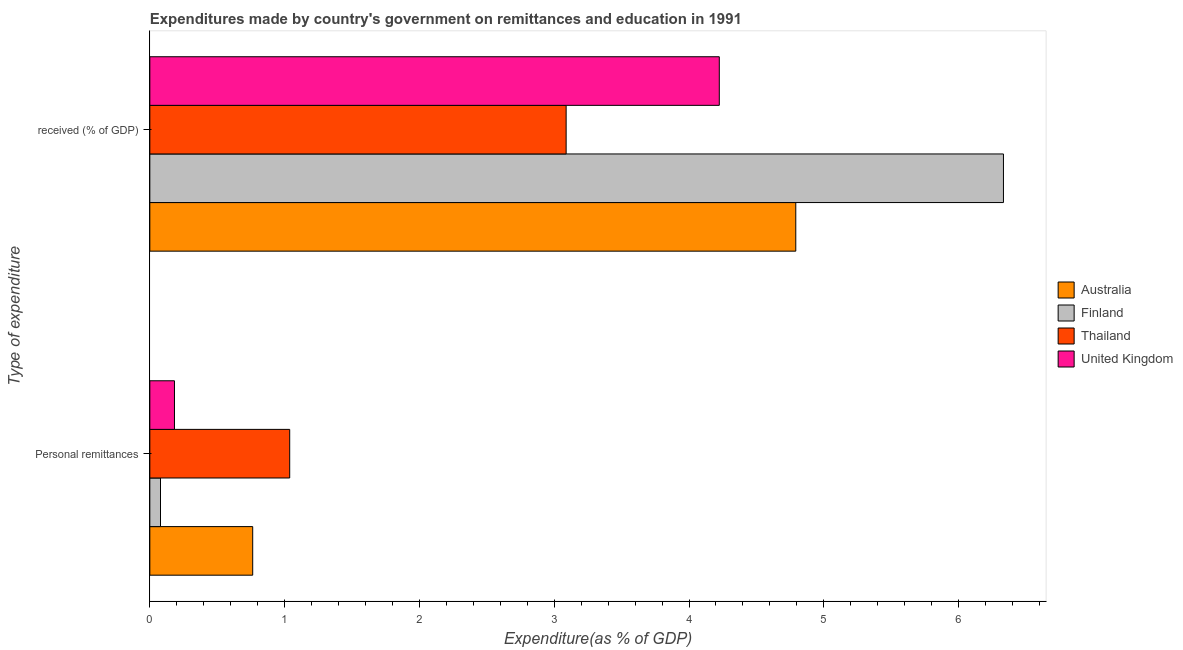How many different coloured bars are there?
Your response must be concise. 4. Are the number of bars per tick equal to the number of legend labels?
Your answer should be very brief. Yes. Are the number of bars on each tick of the Y-axis equal?
Ensure brevity in your answer.  Yes. How many bars are there on the 1st tick from the top?
Offer a very short reply. 4. What is the label of the 2nd group of bars from the top?
Your response must be concise. Personal remittances. What is the expenditure in education in Thailand?
Ensure brevity in your answer.  3.09. Across all countries, what is the maximum expenditure in education?
Offer a terse response. 6.33. Across all countries, what is the minimum expenditure in education?
Your response must be concise. 3.09. In which country was the expenditure in personal remittances maximum?
Provide a short and direct response. Thailand. In which country was the expenditure in education minimum?
Ensure brevity in your answer.  Thailand. What is the total expenditure in personal remittances in the graph?
Provide a succinct answer. 2.06. What is the difference between the expenditure in education in Thailand and that in United Kingdom?
Make the answer very short. -1.14. What is the difference between the expenditure in personal remittances in Australia and the expenditure in education in Thailand?
Ensure brevity in your answer.  -2.33. What is the average expenditure in personal remittances per country?
Provide a short and direct response. 0.52. What is the difference between the expenditure in education and expenditure in personal remittances in Thailand?
Keep it short and to the point. 2.05. In how many countries, is the expenditure in personal remittances greater than 4.4 %?
Keep it short and to the point. 0. What is the ratio of the expenditure in education in Australia to that in Thailand?
Offer a very short reply. 1.55. What does the 4th bar from the bottom in  received (% of GDP) represents?
Keep it short and to the point. United Kingdom. Are all the bars in the graph horizontal?
Give a very brief answer. Yes. What is the difference between two consecutive major ticks on the X-axis?
Make the answer very short. 1. Does the graph contain any zero values?
Your answer should be compact. No. Does the graph contain grids?
Your answer should be compact. No. Where does the legend appear in the graph?
Keep it short and to the point. Center right. How many legend labels are there?
Keep it short and to the point. 4. How are the legend labels stacked?
Make the answer very short. Vertical. What is the title of the graph?
Offer a very short reply. Expenditures made by country's government on remittances and education in 1991. Does "Norway" appear as one of the legend labels in the graph?
Provide a short and direct response. No. What is the label or title of the X-axis?
Provide a succinct answer. Expenditure(as % of GDP). What is the label or title of the Y-axis?
Ensure brevity in your answer.  Type of expenditure. What is the Expenditure(as % of GDP) in Australia in Personal remittances?
Offer a very short reply. 0.76. What is the Expenditure(as % of GDP) in Finland in Personal remittances?
Your answer should be very brief. 0.08. What is the Expenditure(as % of GDP) of Thailand in Personal remittances?
Your response must be concise. 1.04. What is the Expenditure(as % of GDP) in United Kingdom in Personal remittances?
Give a very brief answer. 0.18. What is the Expenditure(as % of GDP) in Australia in  received (% of GDP)?
Offer a terse response. 4.79. What is the Expenditure(as % of GDP) of Finland in  received (% of GDP)?
Offer a terse response. 6.33. What is the Expenditure(as % of GDP) in Thailand in  received (% of GDP)?
Ensure brevity in your answer.  3.09. What is the Expenditure(as % of GDP) of United Kingdom in  received (% of GDP)?
Offer a terse response. 4.22. Across all Type of expenditure, what is the maximum Expenditure(as % of GDP) of Australia?
Make the answer very short. 4.79. Across all Type of expenditure, what is the maximum Expenditure(as % of GDP) in Finland?
Provide a short and direct response. 6.33. Across all Type of expenditure, what is the maximum Expenditure(as % of GDP) in Thailand?
Make the answer very short. 3.09. Across all Type of expenditure, what is the maximum Expenditure(as % of GDP) of United Kingdom?
Provide a short and direct response. 4.22. Across all Type of expenditure, what is the minimum Expenditure(as % of GDP) in Australia?
Ensure brevity in your answer.  0.76. Across all Type of expenditure, what is the minimum Expenditure(as % of GDP) in Finland?
Keep it short and to the point. 0.08. Across all Type of expenditure, what is the minimum Expenditure(as % of GDP) of Thailand?
Offer a terse response. 1.04. Across all Type of expenditure, what is the minimum Expenditure(as % of GDP) of United Kingdom?
Make the answer very short. 0.18. What is the total Expenditure(as % of GDP) in Australia in the graph?
Your answer should be compact. 5.56. What is the total Expenditure(as % of GDP) of Finland in the graph?
Your answer should be very brief. 6.41. What is the total Expenditure(as % of GDP) of Thailand in the graph?
Give a very brief answer. 4.13. What is the total Expenditure(as % of GDP) in United Kingdom in the graph?
Your response must be concise. 4.41. What is the difference between the Expenditure(as % of GDP) in Australia in Personal remittances and that in  received (% of GDP)?
Ensure brevity in your answer.  -4.03. What is the difference between the Expenditure(as % of GDP) of Finland in Personal remittances and that in  received (% of GDP)?
Provide a short and direct response. -6.25. What is the difference between the Expenditure(as % of GDP) in Thailand in Personal remittances and that in  received (% of GDP)?
Offer a very short reply. -2.05. What is the difference between the Expenditure(as % of GDP) in United Kingdom in Personal remittances and that in  received (% of GDP)?
Provide a succinct answer. -4.04. What is the difference between the Expenditure(as % of GDP) of Australia in Personal remittances and the Expenditure(as % of GDP) of Finland in  received (% of GDP)?
Give a very brief answer. -5.57. What is the difference between the Expenditure(as % of GDP) in Australia in Personal remittances and the Expenditure(as % of GDP) in Thailand in  received (% of GDP)?
Your answer should be very brief. -2.33. What is the difference between the Expenditure(as % of GDP) in Australia in Personal remittances and the Expenditure(as % of GDP) in United Kingdom in  received (% of GDP)?
Offer a terse response. -3.46. What is the difference between the Expenditure(as % of GDP) of Finland in Personal remittances and the Expenditure(as % of GDP) of Thailand in  received (% of GDP)?
Your answer should be very brief. -3.01. What is the difference between the Expenditure(as % of GDP) of Finland in Personal remittances and the Expenditure(as % of GDP) of United Kingdom in  received (% of GDP)?
Your answer should be very brief. -4.15. What is the difference between the Expenditure(as % of GDP) in Thailand in Personal remittances and the Expenditure(as % of GDP) in United Kingdom in  received (% of GDP)?
Make the answer very short. -3.19. What is the average Expenditure(as % of GDP) of Australia per Type of expenditure?
Offer a very short reply. 2.78. What is the average Expenditure(as % of GDP) of Finland per Type of expenditure?
Your response must be concise. 3.21. What is the average Expenditure(as % of GDP) of Thailand per Type of expenditure?
Provide a succinct answer. 2.06. What is the average Expenditure(as % of GDP) in United Kingdom per Type of expenditure?
Provide a succinct answer. 2.2. What is the difference between the Expenditure(as % of GDP) in Australia and Expenditure(as % of GDP) in Finland in Personal remittances?
Provide a succinct answer. 0.68. What is the difference between the Expenditure(as % of GDP) of Australia and Expenditure(as % of GDP) of Thailand in Personal remittances?
Provide a succinct answer. -0.27. What is the difference between the Expenditure(as % of GDP) in Australia and Expenditure(as % of GDP) in United Kingdom in Personal remittances?
Ensure brevity in your answer.  0.58. What is the difference between the Expenditure(as % of GDP) in Finland and Expenditure(as % of GDP) in Thailand in Personal remittances?
Provide a short and direct response. -0.96. What is the difference between the Expenditure(as % of GDP) in Finland and Expenditure(as % of GDP) in United Kingdom in Personal remittances?
Make the answer very short. -0.1. What is the difference between the Expenditure(as % of GDP) in Thailand and Expenditure(as % of GDP) in United Kingdom in Personal remittances?
Make the answer very short. 0.85. What is the difference between the Expenditure(as % of GDP) of Australia and Expenditure(as % of GDP) of Finland in  received (% of GDP)?
Provide a succinct answer. -1.54. What is the difference between the Expenditure(as % of GDP) of Australia and Expenditure(as % of GDP) of Thailand in  received (% of GDP)?
Keep it short and to the point. 1.7. What is the difference between the Expenditure(as % of GDP) of Australia and Expenditure(as % of GDP) of United Kingdom in  received (% of GDP)?
Your response must be concise. 0.57. What is the difference between the Expenditure(as % of GDP) in Finland and Expenditure(as % of GDP) in Thailand in  received (% of GDP)?
Your answer should be very brief. 3.24. What is the difference between the Expenditure(as % of GDP) in Finland and Expenditure(as % of GDP) in United Kingdom in  received (% of GDP)?
Offer a very short reply. 2.11. What is the difference between the Expenditure(as % of GDP) in Thailand and Expenditure(as % of GDP) in United Kingdom in  received (% of GDP)?
Your answer should be very brief. -1.14. What is the ratio of the Expenditure(as % of GDP) of Australia in Personal remittances to that in  received (% of GDP)?
Keep it short and to the point. 0.16. What is the ratio of the Expenditure(as % of GDP) of Finland in Personal remittances to that in  received (% of GDP)?
Make the answer very short. 0.01. What is the ratio of the Expenditure(as % of GDP) of Thailand in Personal remittances to that in  received (% of GDP)?
Your response must be concise. 0.34. What is the ratio of the Expenditure(as % of GDP) of United Kingdom in Personal remittances to that in  received (% of GDP)?
Your answer should be very brief. 0.04. What is the difference between the highest and the second highest Expenditure(as % of GDP) of Australia?
Provide a short and direct response. 4.03. What is the difference between the highest and the second highest Expenditure(as % of GDP) in Finland?
Give a very brief answer. 6.25. What is the difference between the highest and the second highest Expenditure(as % of GDP) of Thailand?
Provide a succinct answer. 2.05. What is the difference between the highest and the second highest Expenditure(as % of GDP) in United Kingdom?
Your response must be concise. 4.04. What is the difference between the highest and the lowest Expenditure(as % of GDP) in Australia?
Keep it short and to the point. 4.03. What is the difference between the highest and the lowest Expenditure(as % of GDP) in Finland?
Your answer should be very brief. 6.25. What is the difference between the highest and the lowest Expenditure(as % of GDP) of Thailand?
Give a very brief answer. 2.05. What is the difference between the highest and the lowest Expenditure(as % of GDP) of United Kingdom?
Offer a terse response. 4.04. 